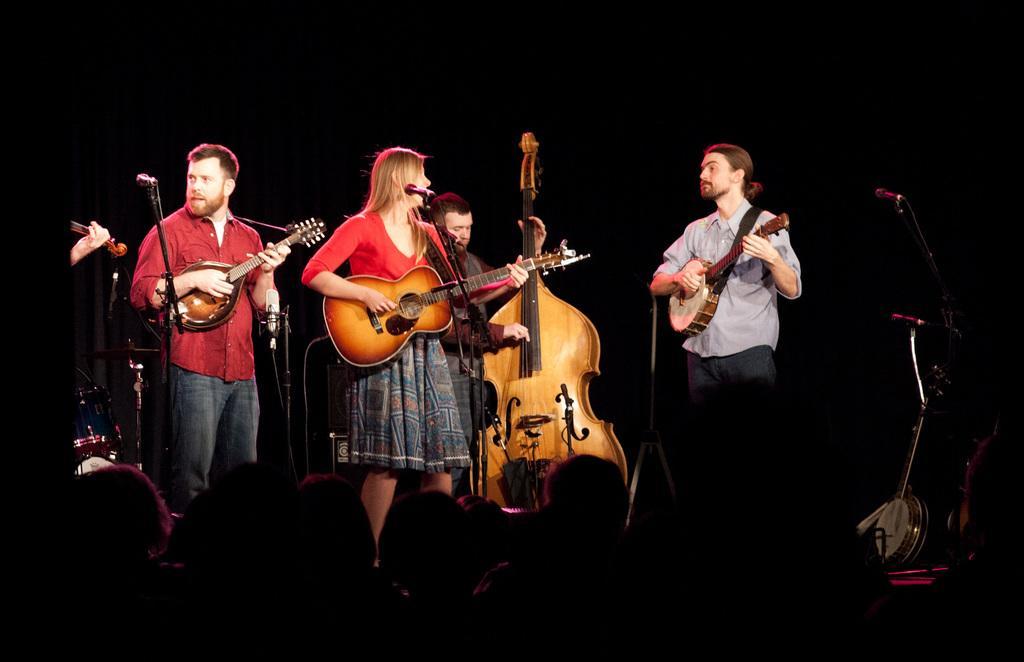In one or two sentences, can you explain what this image depicts? Here we see four men on the dais, playing a guitar and a man playing violin on the stage. 